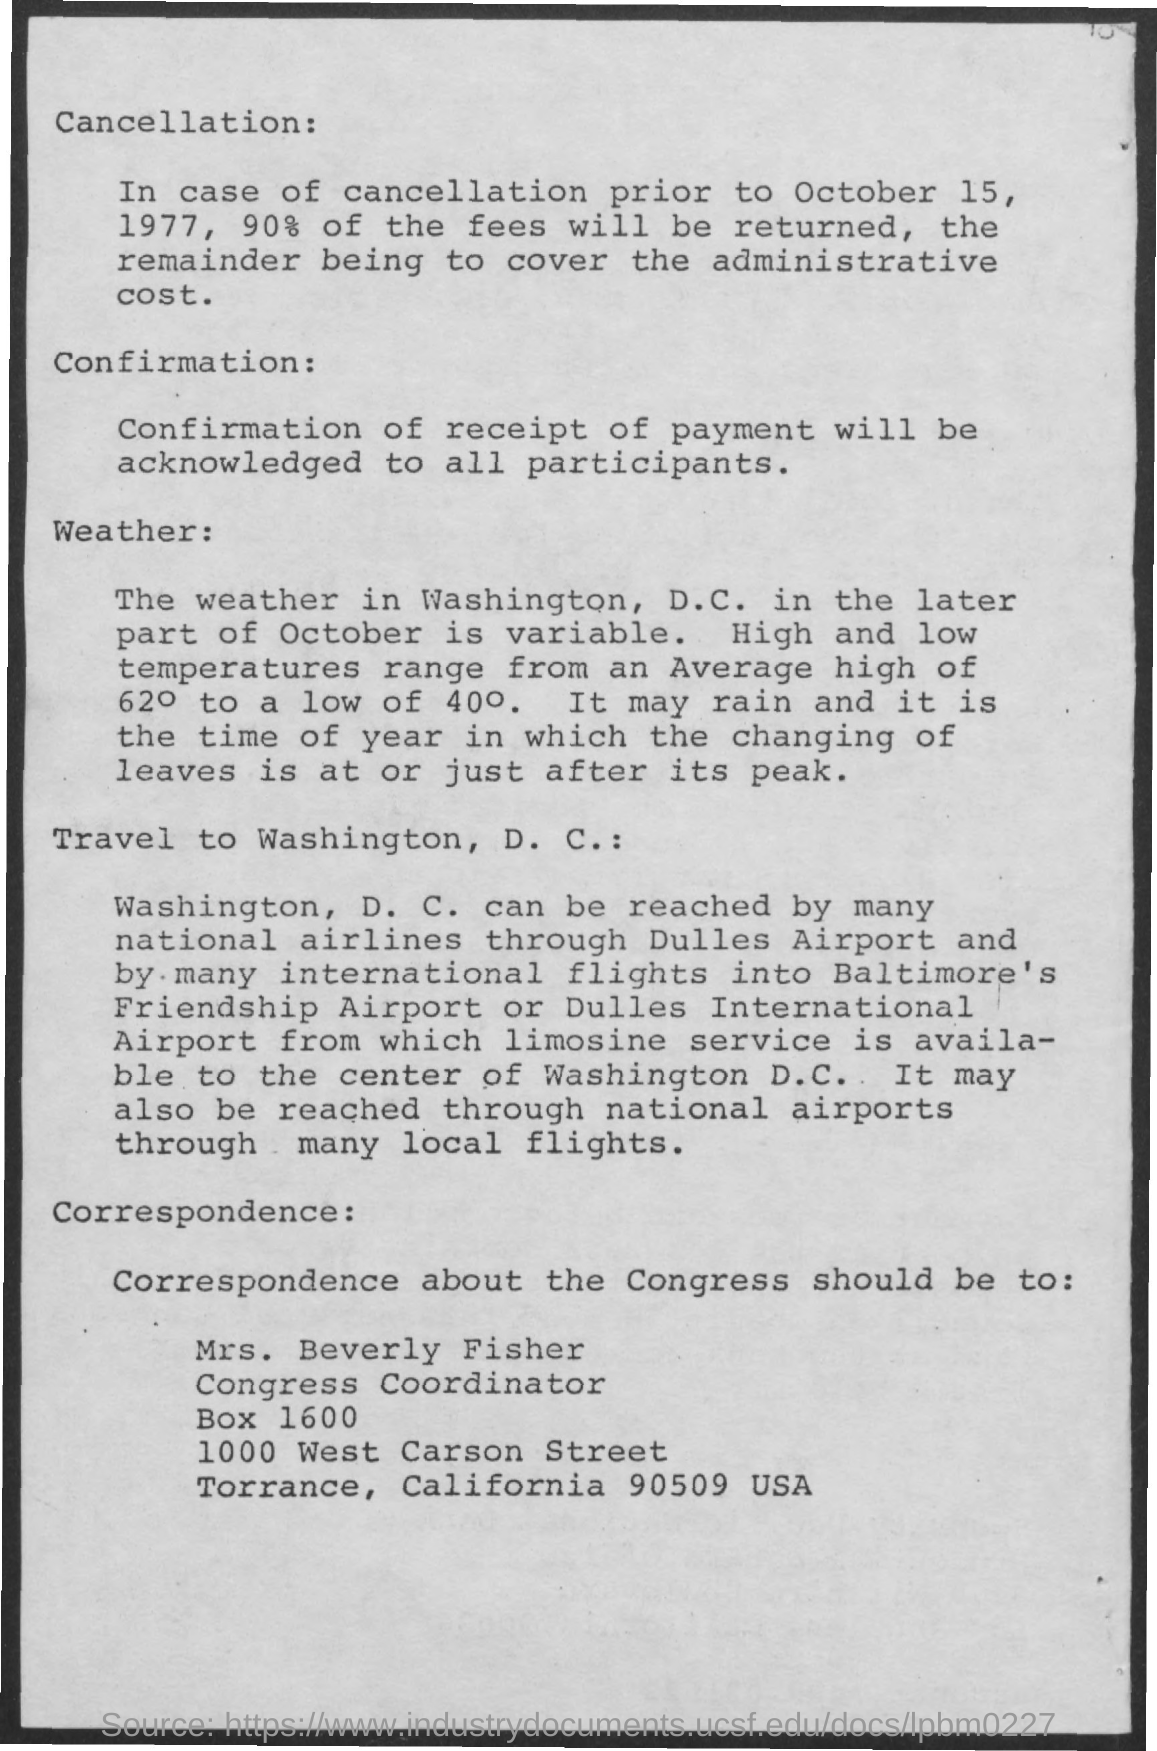Give some essential details in this illustration. In case the cancellation occurred prior to October 15, 1977, 90% of the fee will be returned. 